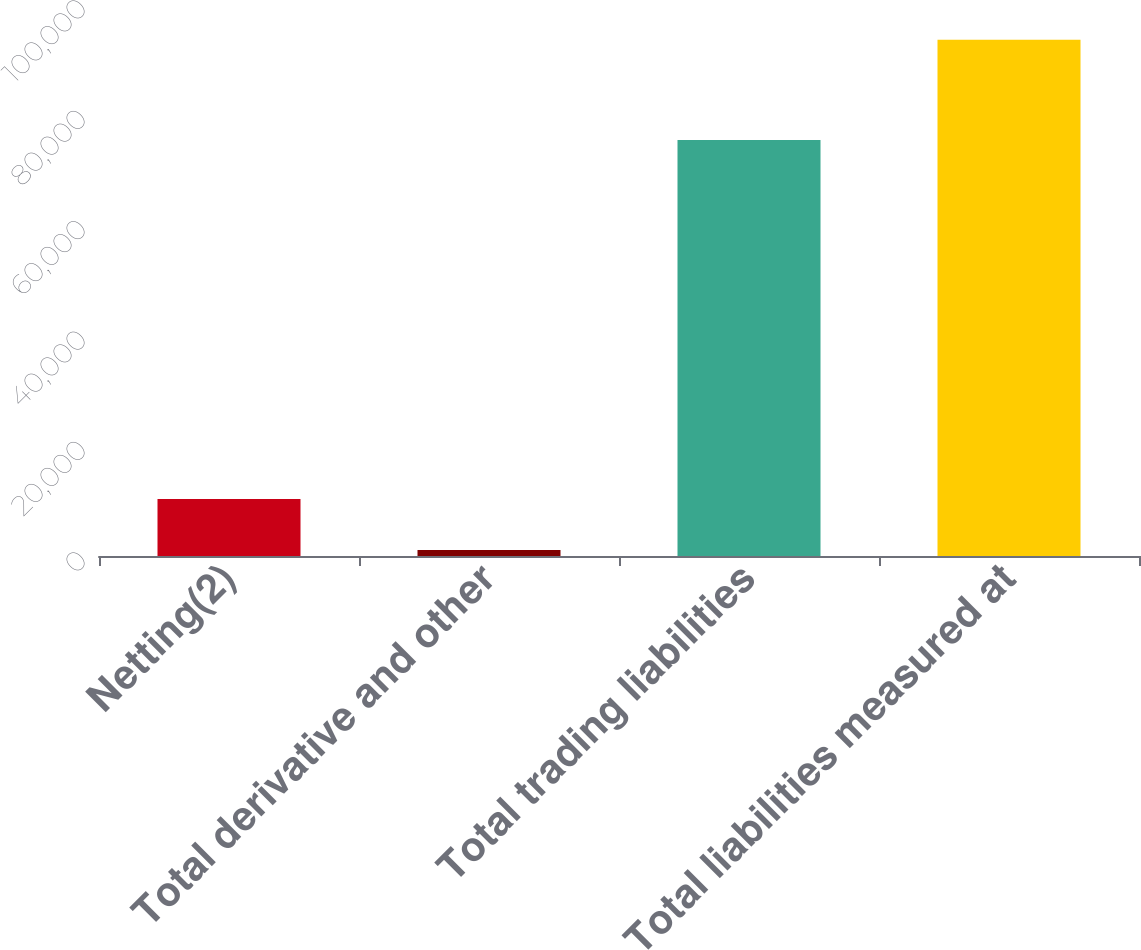<chart> <loc_0><loc_0><loc_500><loc_500><bar_chart><fcel>Netting(2)<fcel>Total derivative and other<fcel>Total trading liabilities<fcel>Total liabilities measured at<nl><fcel>10320<fcel>1073<fcel>75364<fcel>93543<nl></chart> 